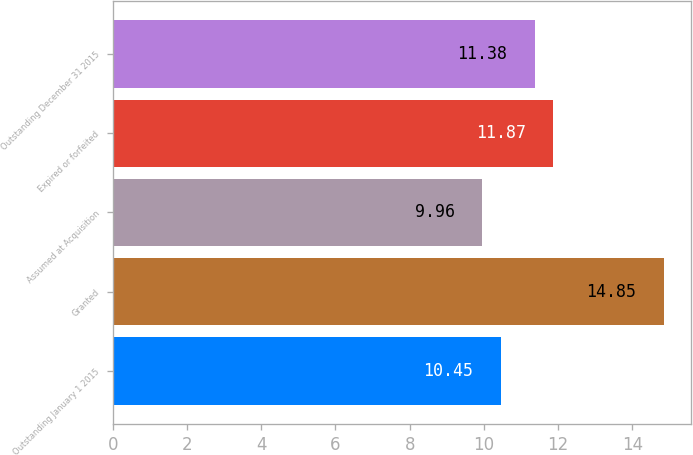<chart> <loc_0><loc_0><loc_500><loc_500><bar_chart><fcel>Outstanding January 1 2015<fcel>Granted<fcel>Assumed at Acquisition<fcel>Expired or forfeited<fcel>Outstanding December 31 2015<nl><fcel>10.45<fcel>14.85<fcel>9.96<fcel>11.87<fcel>11.38<nl></chart> 